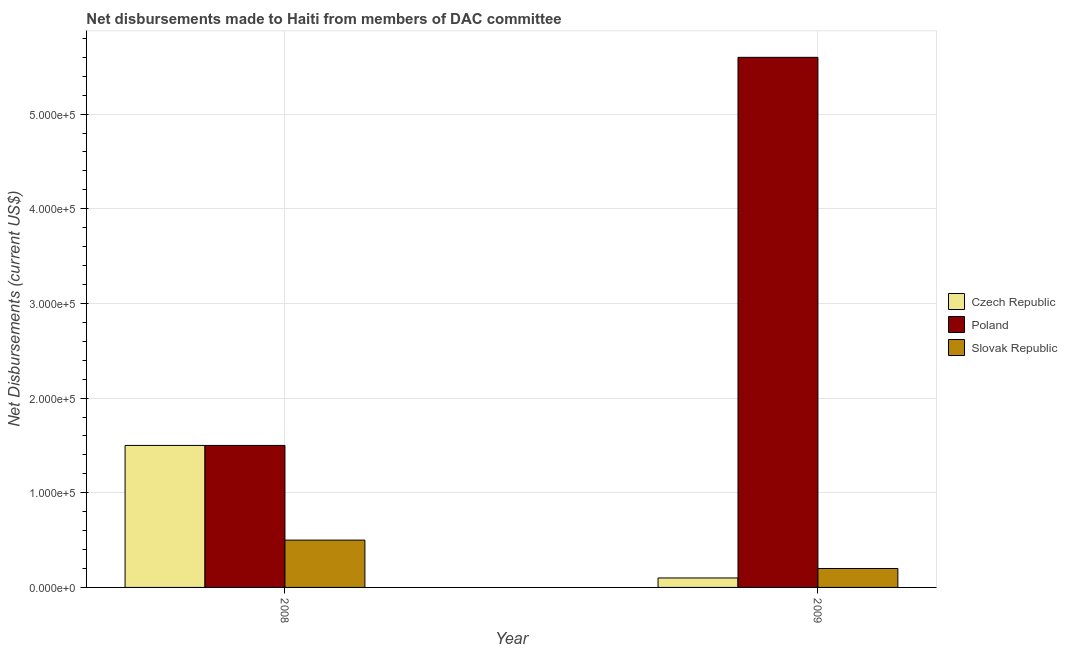Are the number of bars per tick equal to the number of legend labels?
Ensure brevity in your answer.  Yes. Are the number of bars on each tick of the X-axis equal?
Your answer should be compact. Yes. How many bars are there on the 2nd tick from the left?
Provide a short and direct response. 3. What is the label of the 2nd group of bars from the left?
Your answer should be compact. 2009. What is the net disbursements made by slovak republic in 2009?
Offer a very short reply. 2.00e+04. Across all years, what is the maximum net disbursements made by czech republic?
Make the answer very short. 1.50e+05. Across all years, what is the minimum net disbursements made by slovak republic?
Keep it short and to the point. 2.00e+04. In which year was the net disbursements made by slovak republic minimum?
Your response must be concise. 2009. What is the total net disbursements made by slovak republic in the graph?
Your answer should be compact. 7.00e+04. What is the difference between the net disbursements made by czech republic in 2008 and that in 2009?
Offer a very short reply. 1.40e+05. What is the difference between the net disbursements made by slovak republic in 2008 and the net disbursements made by czech republic in 2009?
Offer a very short reply. 3.00e+04. What is the average net disbursements made by slovak republic per year?
Your answer should be compact. 3.50e+04. In how many years, is the net disbursements made by slovak republic greater than 380000 US$?
Give a very brief answer. 0. What is the ratio of the net disbursements made by poland in 2008 to that in 2009?
Make the answer very short. 0.27. Is the net disbursements made by czech republic in 2008 less than that in 2009?
Provide a succinct answer. No. What does the 1st bar from the left in 2008 represents?
Offer a very short reply. Czech Republic. How many bars are there?
Give a very brief answer. 6. Are all the bars in the graph horizontal?
Your answer should be compact. No. How many years are there in the graph?
Provide a succinct answer. 2. What is the difference between two consecutive major ticks on the Y-axis?
Offer a very short reply. 1.00e+05. Are the values on the major ticks of Y-axis written in scientific E-notation?
Make the answer very short. Yes. Does the graph contain any zero values?
Keep it short and to the point. No. Does the graph contain grids?
Keep it short and to the point. Yes. How many legend labels are there?
Your response must be concise. 3. How are the legend labels stacked?
Your answer should be very brief. Vertical. What is the title of the graph?
Provide a succinct answer. Net disbursements made to Haiti from members of DAC committee. Does "Interest" appear as one of the legend labels in the graph?
Your response must be concise. No. What is the label or title of the Y-axis?
Provide a succinct answer. Net Disbursements (current US$). What is the Net Disbursements (current US$) in Czech Republic in 2008?
Give a very brief answer. 1.50e+05. What is the Net Disbursements (current US$) of Poland in 2008?
Make the answer very short. 1.50e+05. What is the Net Disbursements (current US$) of Czech Republic in 2009?
Offer a very short reply. 10000. What is the Net Disbursements (current US$) of Poland in 2009?
Your response must be concise. 5.60e+05. Across all years, what is the maximum Net Disbursements (current US$) in Czech Republic?
Provide a succinct answer. 1.50e+05. Across all years, what is the maximum Net Disbursements (current US$) in Poland?
Ensure brevity in your answer.  5.60e+05. Across all years, what is the minimum Net Disbursements (current US$) of Czech Republic?
Your answer should be very brief. 10000. Across all years, what is the minimum Net Disbursements (current US$) of Poland?
Your answer should be very brief. 1.50e+05. Across all years, what is the minimum Net Disbursements (current US$) of Slovak Republic?
Keep it short and to the point. 2.00e+04. What is the total Net Disbursements (current US$) in Poland in the graph?
Offer a very short reply. 7.10e+05. What is the difference between the Net Disbursements (current US$) of Czech Republic in 2008 and that in 2009?
Provide a short and direct response. 1.40e+05. What is the difference between the Net Disbursements (current US$) in Poland in 2008 and that in 2009?
Make the answer very short. -4.10e+05. What is the difference between the Net Disbursements (current US$) of Czech Republic in 2008 and the Net Disbursements (current US$) of Poland in 2009?
Ensure brevity in your answer.  -4.10e+05. What is the difference between the Net Disbursements (current US$) of Czech Republic in 2008 and the Net Disbursements (current US$) of Slovak Republic in 2009?
Keep it short and to the point. 1.30e+05. What is the average Net Disbursements (current US$) of Poland per year?
Your response must be concise. 3.55e+05. What is the average Net Disbursements (current US$) of Slovak Republic per year?
Your answer should be very brief. 3.50e+04. In the year 2009, what is the difference between the Net Disbursements (current US$) in Czech Republic and Net Disbursements (current US$) in Poland?
Offer a very short reply. -5.50e+05. In the year 2009, what is the difference between the Net Disbursements (current US$) in Czech Republic and Net Disbursements (current US$) in Slovak Republic?
Provide a short and direct response. -10000. In the year 2009, what is the difference between the Net Disbursements (current US$) in Poland and Net Disbursements (current US$) in Slovak Republic?
Give a very brief answer. 5.40e+05. What is the ratio of the Net Disbursements (current US$) of Czech Republic in 2008 to that in 2009?
Keep it short and to the point. 15. What is the ratio of the Net Disbursements (current US$) of Poland in 2008 to that in 2009?
Provide a succinct answer. 0.27. What is the ratio of the Net Disbursements (current US$) of Slovak Republic in 2008 to that in 2009?
Your answer should be very brief. 2.5. What is the difference between the highest and the second highest Net Disbursements (current US$) of Czech Republic?
Provide a short and direct response. 1.40e+05. What is the difference between the highest and the second highest Net Disbursements (current US$) in Poland?
Your response must be concise. 4.10e+05. What is the difference between the highest and the second highest Net Disbursements (current US$) of Slovak Republic?
Offer a terse response. 3.00e+04. 